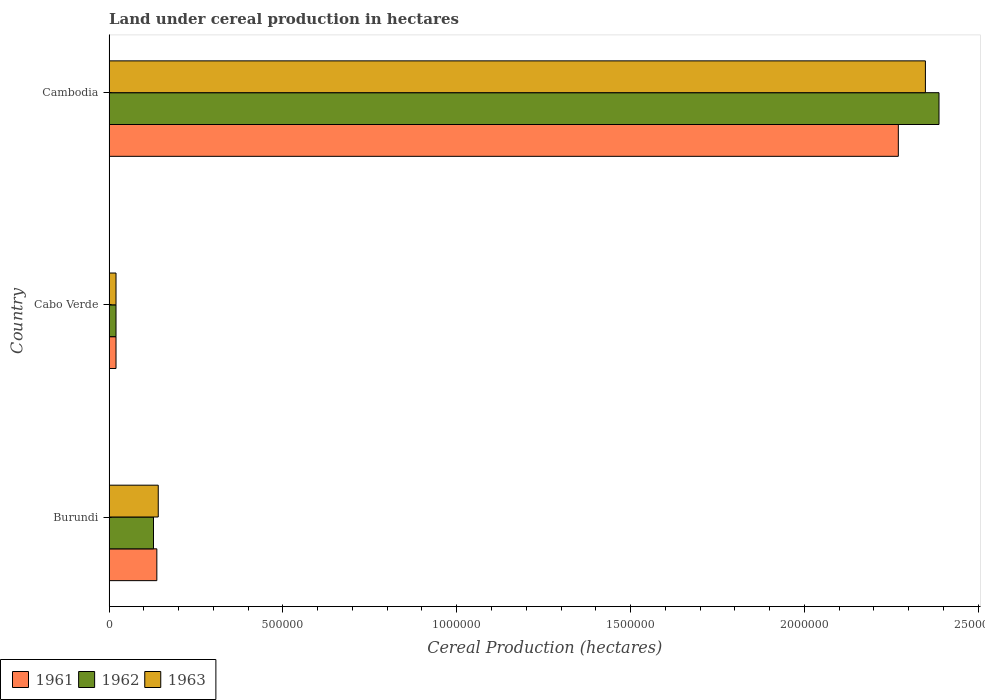How many different coloured bars are there?
Offer a very short reply. 3. How many groups of bars are there?
Keep it short and to the point. 3. Are the number of bars per tick equal to the number of legend labels?
Give a very brief answer. Yes. How many bars are there on the 3rd tick from the top?
Provide a short and direct response. 3. What is the label of the 2nd group of bars from the top?
Your answer should be compact. Cabo Verde. In how many cases, is the number of bars for a given country not equal to the number of legend labels?
Offer a very short reply. 0. Across all countries, what is the maximum land under cereal production in 1963?
Make the answer very short. 2.35e+06. Across all countries, what is the minimum land under cereal production in 1962?
Provide a short and direct response. 2.00e+04. In which country was the land under cereal production in 1963 maximum?
Give a very brief answer. Cambodia. In which country was the land under cereal production in 1962 minimum?
Provide a succinct answer. Cabo Verde. What is the total land under cereal production in 1961 in the graph?
Provide a succinct answer. 2.43e+06. What is the difference between the land under cereal production in 1963 in Cabo Verde and that in Cambodia?
Offer a very short reply. -2.33e+06. What is the difference between the land under cereal production in 1961 in Burundi and the land under cereal production in 1963 in Cabo Verde?
Make the answer very short. 1.17e+05. What is the average land under cereal production in 1963 per country?
Your response must be concise. 8.36e+05. What is the difference between the land under cereal production in 1961 and land under cereal production in 1963 in Cabo Verde?
Provide a succinct answer. 0. In how many countries, is the land under cereal production in 1962 greater than 400000 hectares?
Offer a very short reply. 1. What is the ratio of the land under cereal production in 1963 in Burundi to that in Cambodia?
Your answer should be very brief. 0.06. Is the land under cereal production in 1963 in Burundi less than that in Cabo Verde?
Offer a terse response. No. What is the difference between the highest and the second highest land under cereal production in 1961?
Your response must be concise. 2.13e+06. What is the difference between the highest and the lowest land under cereal production in 1962?
Keep it short and to the point. 2.37e+06. In how many countries, is the land under cereal production in 1963 greater than the average land under cereal production in 1963 taken over all countries?
Give a very brief answer. 1. Is the sum of the land under cereal production in 1963 in Burundi and Cambodia greater than the maximum land under cereal production in 1962 across all countries?
Ensure brevity in your answer.  Yes. What does the 3rd bar from the bottom in Cambodia represents?
Provide a short and direct response. 1963. How many bars are there?
Offer a very short reply. 9. Are all the bars in the graph horizontal?
Provide a succinct answer. Yes. How many countries are there in the graph?
Offer a terse response. 3. What is the title of the graph?
Ensure brevity in your answer.  Land under cereal production in hectares. Does "1987" appear as one of the legend labels in the graph?
Make the answer very short. No. What is the label or title of the X-axis?
Make the answer very short. Cereal Production (hectares). What is the label or title of the Y-axis?
Keep it short and to the point. Country. What is the Cereal Production (hectares) in 1961 in Burundi?
Offer a terse response. 1.37e+05. What is the Cereal Production (hectares) of 1962 in Burundi?
Offer a very short reply. 1.28e+05. What is the Cereal Production (hectares) in 1963 in Burundi?
Keep it short and to the point. 1.41e+05. What is the Cereal Production (hectares) in 1961 in Cabo Verde?
Ensure brevity in your answer.  2.00e+04. What is the Cereal Production (hectares) in 1962 in Cabo Verde?
Offer a terse response. 2.00e+04. What is the Cereal Production (hectares) of 1963 in Cabo Verde?
Offer a very short reply. 2.00e+04. What is the Cereal Production (hectares) in 1961 in Cambodia?
Make the answer very short. 2.27e+06. What is the Cereal Production (hectares) of 1962 in Cambodia?
Provide a succinct answer. 2.39e+06. What is the Cereal Production (hectares) of 1963 in Cambodia?
Provide a succinct answer. 2.35e+06. Across all countries, what is the maximum Cereal Production (hectares) in 1961?
Offer a very short reply. 2.27e+06. Across all countries, what is the maximum Cereal Production (hectares) of 1962?
Offer a very short reply. 2.39e+06. Across all countries, what is the maximum Cereal Production (hectares) of 1963?
Your answer should be very brief. 2.35e+06. Across all countries, what is the minimum Cereal Production (hectares) of 1961?
Your response must be concise. 2.00e+04. Across all countries, what is the minimum Cereal Production (hectares) of 1962?
Provide a short and direct response. 2.00e+04. What is the total Cereal Production (hectares) of 1961 in the graph?
Ensure brevity in your answer.  2.43e+06. What is the total Cereal Production (hectares) of 1962 in the graph?
Your answer should be very brief. 2.53e+06. What is the total Cereal Production (hectares) of 1963 in the graph?
Provide a succinct answer. 2.51e+06. What is the difference between the Cereal Production (hectares) in 1961 in Burundi and that in Cabo Verde?
Give a very brief answer. 1.17e+05. What is the difference between the Cereal Production (hectares) of 1962 in Burundi and that in Cabo Verde?
Your answer should be very brief. 1.08e+05. What is the difference between the Cereal Production (hectares) of 1963 in Burundi and that in Cabo Verde?
Give a very brief answer. 1.21e+05. What is the difference between the Cereal Production (hectares) of 1961 in Burundi and that in Cambodia?
Your answer should be very brief. -2.13e+06. What is the difference between the Cereal Production (hectares) of 1962 in Burundi and that in Cambodia?
Keep it short and to the point. -2.26e+06. What is the difference between the Cereal Production (hectares) of 1963 in Burundi and that in Cambodia?
Make the answer very short. -2.21e+06. What is the difference between the Cereal Production (hectares) in 1961 in Cabo Verde and that in Cambodia?
Ensure brevity in your answer.  -2.25e+06. What is the difference between the Cereal Production (hectares) in 1962 in Cabo Verde and that in Cambodia?
Keep it short and to the point. -2.37e+06. What is the difference between the Cereal Production (hectares) in 1963 in Cabo Verde and that in Cambodia?
Provide a short and direct response. -2.33e+06. What is the difference between the Cereal Production (hectares) of 1961 in Burundi and the Cereal Production (hectares) of 1962 in Cabo Verde?
Provide a succinct answer. 1.17e+05. What is the difference between the Cereal Production (hectares) in 1961 in Burundi and the Cereal Production (hectares) in 1963 in Cabo Verde?
Provide a succinct answer. 1.17e+05. What is the difference between the Cereal Production (hectares) in 1962 in Burundi and the Cereal Production (hectares) in 1963 in Cabo Verde?
Keep it short and to the point. 1.08e+05. What is the difference between the Cereal Production (hectares) in 1961 in Burundi and the Cereal Production (hectares) in 1962 in Cambodia?
Your answer should be compact. -2.25e+06. What is the difference between the Cereal Production (hectares) of 1961 in Burundi and the Cereal Production (hectares) of 1963 in Cambodia?
Offer a terse response. -2.21e+06. What is the difference between the Cereal Production (hectares) in 1962 in Burundi and the Cereal Production (hectares) in 1963 in Cambodia?
Make the answer very short. -2.22e+06. What is the difference between the Cereal Production (hectares) in 1961 in Cabo Verde and the Cereal Production (hectares) in 1962 in Cambodia?
Keep it short and to the point. -2.37e+06. What is the difference between the Cereal Production (hectares) in 1961 in Cabo Verde and the Cereal Production (hectares) in 1963 in Cambodia?
Offer a very short reply. -2.33e+06. What is the difference between the Cereal Production (hectares) of 1962 in Cabo Verde and the Cereal Production (hectares) of 1963 in Cambodia?
Keep it short and to the point. -2.33e+06. What is the average Cereal Production (hectares) of 1961 per country?
Offer a very short reply. 8.09e+05. What is the average Cereal Production (hectares) of 1962 per country?
Offer a terse response. 8.45e+05. What is the average Cereal Production (hectares) of 1963 per country?
Keep it short and to the point. 8.36e+05. What is the difference between the Cereal Production (hectares) of 1961 and Cereal Production (hectares) of 1962 in Burundi?
Give a very brief answer. 9597. What is the difference between the Cereal Production (hectares) in 1961 and Cereal Production (hectares) in 1963 in Burundi?
Your answer should be very brief. -4063. What is the difference between the Cereal Production (hectares) of 1962 and Cereal Production (hectares) of 1963 in Burundi?
Your answer should be compact. -1.37e+04. What is the difference between the Cereal Production (hectares) of 1962 and Cereal Production (hectares) of 1963 in Cabo Verde?
Your answer should be compact. 0. What is the difference between the Cereal Production (hectares) of 1961 and Cereal Production (hectares) of 1962 in Cambodia?
Your answer should be compact. -1.17e+05. What is the difference between the Cereal Production (hectares) of 1961 and Cereal Production (hectares) of 1963 in Cambodia?
Keep it short and to the point. -7.79e+04. What is the difference between the Cereal Production (hectares) in 1962 and Cereal Production (hectares) in 1963 in Cambodia?
Give a very brief answer. 3.91e+04. What is the ratio of the Cereal Production (hectares) of 1961 in Burundi to that in Cabo Verde?
Offer a very short reply. 6.87. What is the ratio of the Cereal Production (hectares) in 1962 in Burundi to that in Cabo Verde?
Provide a succinct answer. 6.39. What is the ratio of the Cereal Production (hectares) of 1963 in Burundi to that in Cabo Verde?
Your response must be concise. 7.07. What is the ratio of the Cereal Production (hectares) in 1961 in Burundi to that in Cambodia?
Give a very brief answer. 0.06. What is the ratio of the Cereal Production (hectares) in 1962 in Burundi to that in Cambodia?
Keep it short and to the point. 0.05. What is the ratio of the Cereal Production (hectares) of 1963 in Burundi to that in Cambodia?
Give a very brief answer. 0.06. What is the ratio of the Cereal Production (hectares) of 1961 in Cabo Verde to that in Cambodia?
Ensure brevity in your answer.  0.01. What is the ratio of the Cereal Production (hectares) in 1962 in Cabo Verde to that in Cambodia?
Offer a terse response. 0.01. What is the ratio of the Cereal Production (hectares) of 1963 in Cabo Verde to that in Cambodia?
Your answer should be compact. 0.01. What is the difference between the highest and the second highest Cereal Production (hectares) in 1961?
Provide a succinct answer. 2.13e+06. What is the difference between the highest and the second highest Cereal Production (hectares) in 1962?
Ensure brevity in your answer.  2.26e+06. What is the difference between the highest and the second highest Cereal Production (hectares) of 1963?
Offer a terse response. 2.21e+06. What is the difference between the highest and the lowest Cereal Production (hectares) in 1961?
Give a very brief answer. 2.25e+06. What is the difference between the highest and the lowest Cereal Production (hectares) in 1962?
Make the answer very short. 2.37e+06. What is the difference between the highest and the lowest Cereal Production (hectares) in 1963?
Offer a terse response. 2.33e+06. 